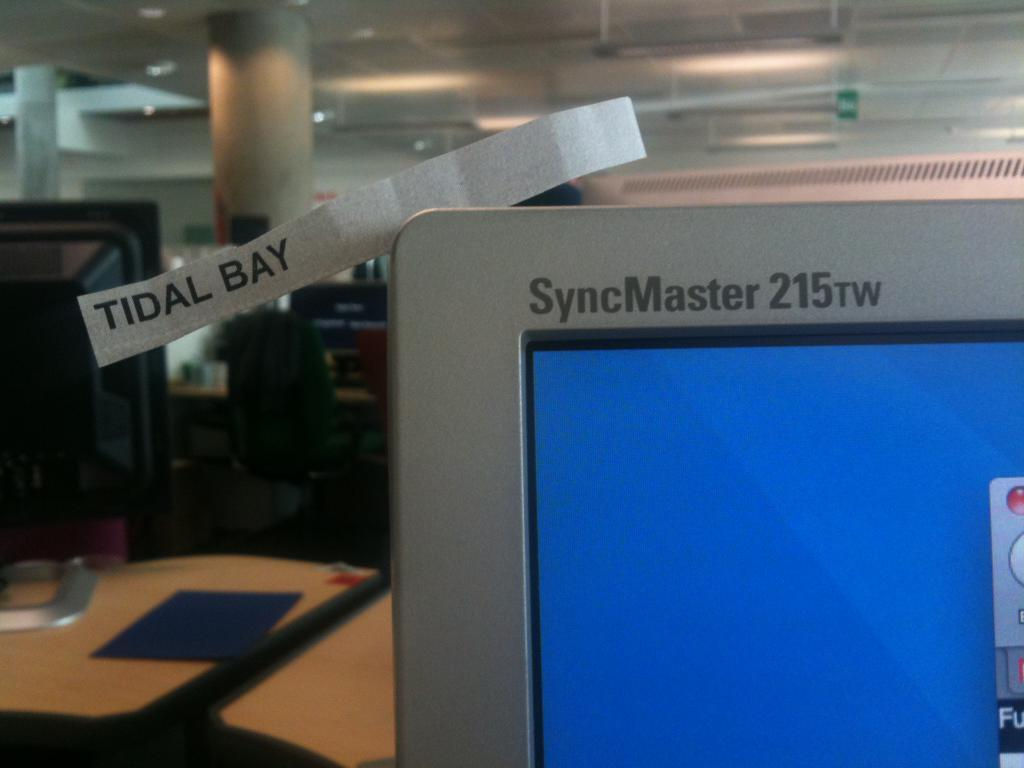Provide a one-sentence caption for the provided image. a computer with the name syncmaster 215rw on it. 